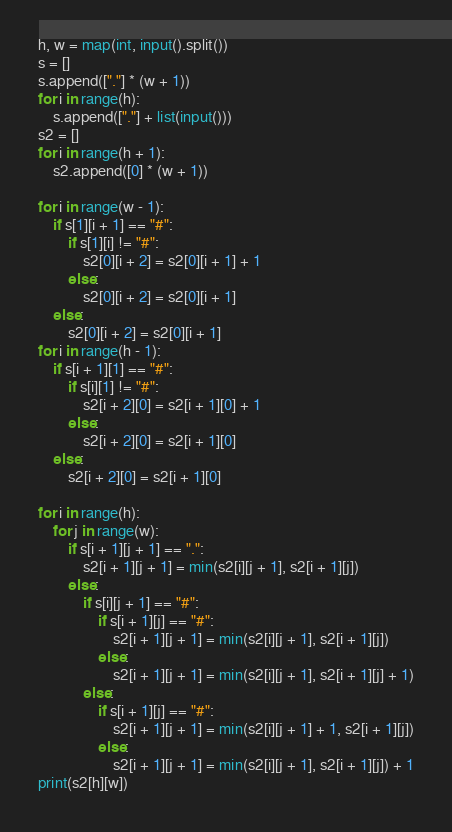Convert code to text. <code><loc_0><loc_0><loc_500><loc_500><_Python_>h, w = map(int, input().split())
s = []
s.append(["."] * (w + 1))
for i in range(h):
    s.append(["."] + list(input()))
s2 = []
for i in range(h + 1):
    s2.append([0] * (w + 1))

for i in range(w - 1):
    if s[1][i + 1] == "#":
        if s[1][i] != "#":
            s2[0][i + 2] = s2[0][i + 1] + 1
        else:
            s2[0][i + 2] = s2[0][i + 1]
    else:
        s2[0][i + 2] = s2[0][i + 1]
for i in range(h - 1):
    if s[i + 1][1] == "#":
        if s[i][1] != "#":
            s2[i + 2][0] = s2[i + 1][0] + 1
        else:
            s2[i + 2][0] = s2[i + 1][0]
    else:
        s2[i + 2][0] = s2[i + 1][0]

for i in range(h):
    for j in range(w):
        if s[i + 1][j + 1] == ".":
            s2[i + 1][j + 1] = min(s2[i][j + 1], s2[i + 1][j])
        else:
            if s[i][j + 1] == "#":
                if s[i + 1][j] == "#":
                    s2[i + 1][j + 1] = min(s2[i][j + 1], s2[i + 1][j])
                else:
                    s2[i + 1][j + 1] = min(s2[i][j + 1], s2[i + 1][j] + 1)
            else:
                if s[i + 1][j] == "#":
                    s2[i + 1][j + 1] = min(s2[i][j + 1] + 1, s2[i + 1][j])
                else:
                    s2[i + 1][j + 1] = min(s2[i][j + 1], s2[i + 1][j]) + 1
print(s2[h][w])</code> 